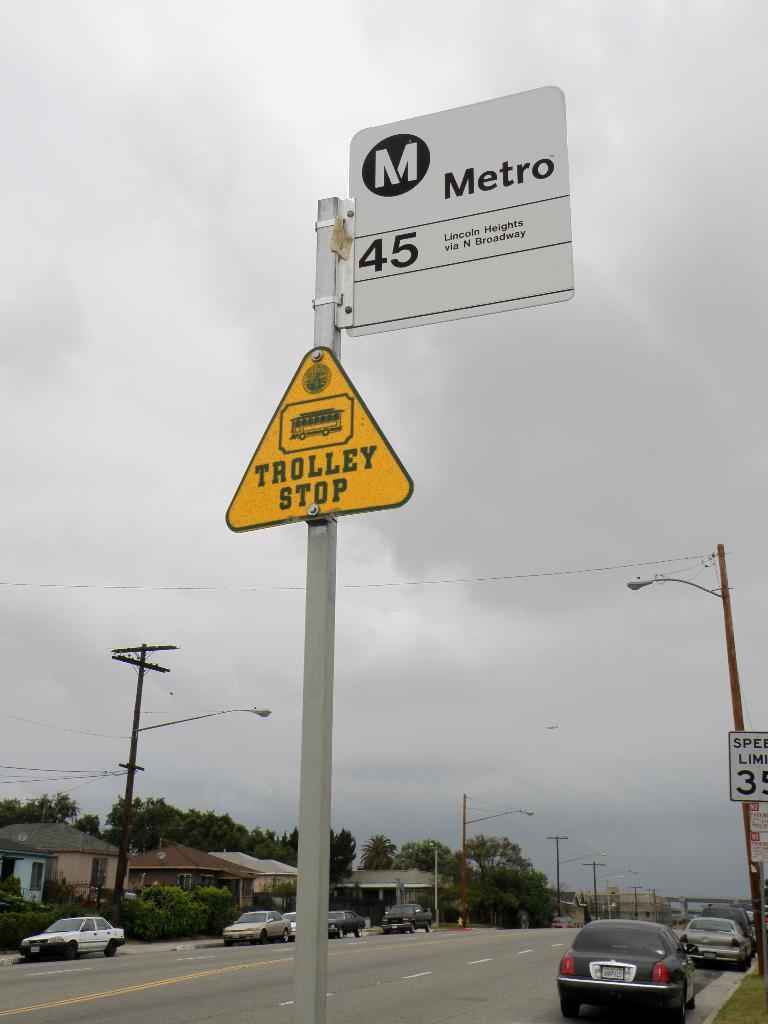Can you describe this image briefly? This image is taken outdoors. At the bottom of the image there is a road. At the top of the image there is a sky with clouds. In the middle of the image there is a signboard with a text on it. On the left side of the image there are a few houses, trees and plants. There are a few poles with street lights and sign boards. A few cars are parked on the road. On the right side of the image there is a street light and a few cars are parked on the road. 